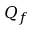<formula> <loc_0><loc_0><loc_500><loc_500>Q _ { f }</formula> 